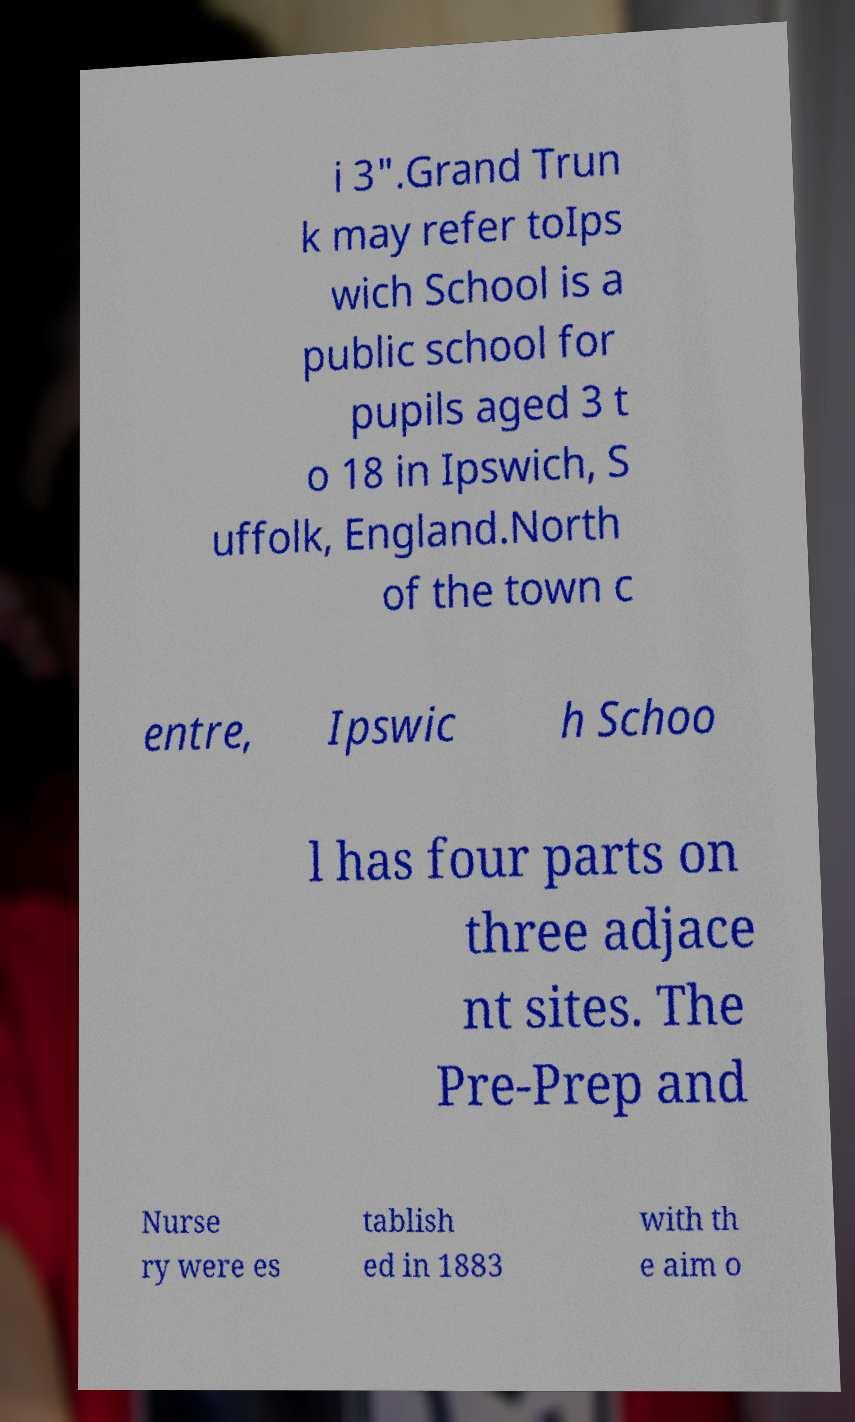Please identify and transcribe the text found in this image. i 3".Grand Trun k may refer toIps wich School is a public school for pupils aged 3 t o 18 in Ipswich, S uffolk, England.North of the town c entre, Ipswic h Schoo l has four parts on three adjace nt sites. The Pre-Prep and Nurse ry were es tablish ed in 1883 with th e aim o 